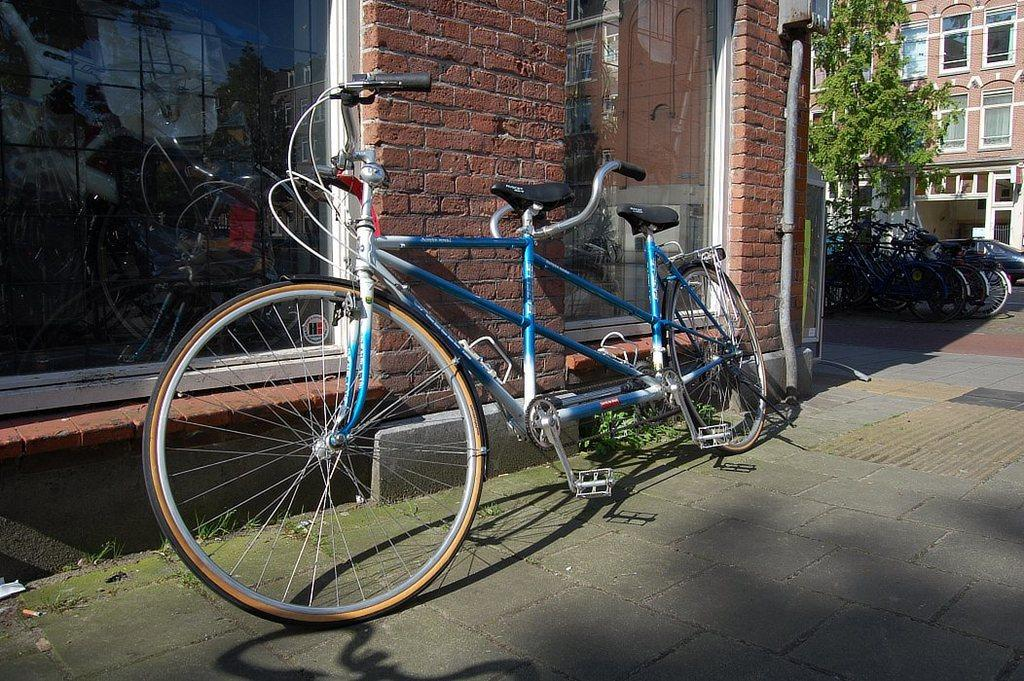What can be seen parked on the road in the image? There are fleets of bicycles parked on the road. What time of day is the image taken? The image is taken during a day. What can be seen in the background of the image? There is a wall of bricks, a glass element, trees, and buildings in the background. What type of ghost can be seen interacting with the bicycles in the image? There are no ghosts present in the image; it features fleets of bicycles parked on the road. What kind of creature is hiding behind the wall of bricks in the image? There are no creatures present in the image; it only features fleets of bicycles, a wall of bricks, and other background elements. 